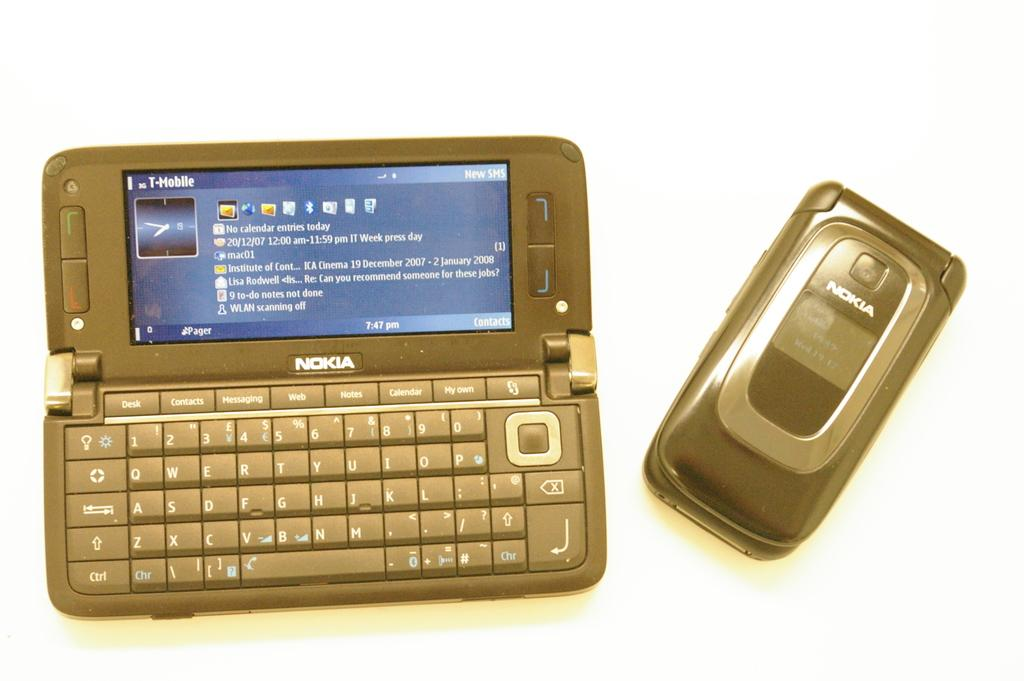<image>
Share a concise interpretation of the image provided. Two different products Nokia company, one is a phone. 